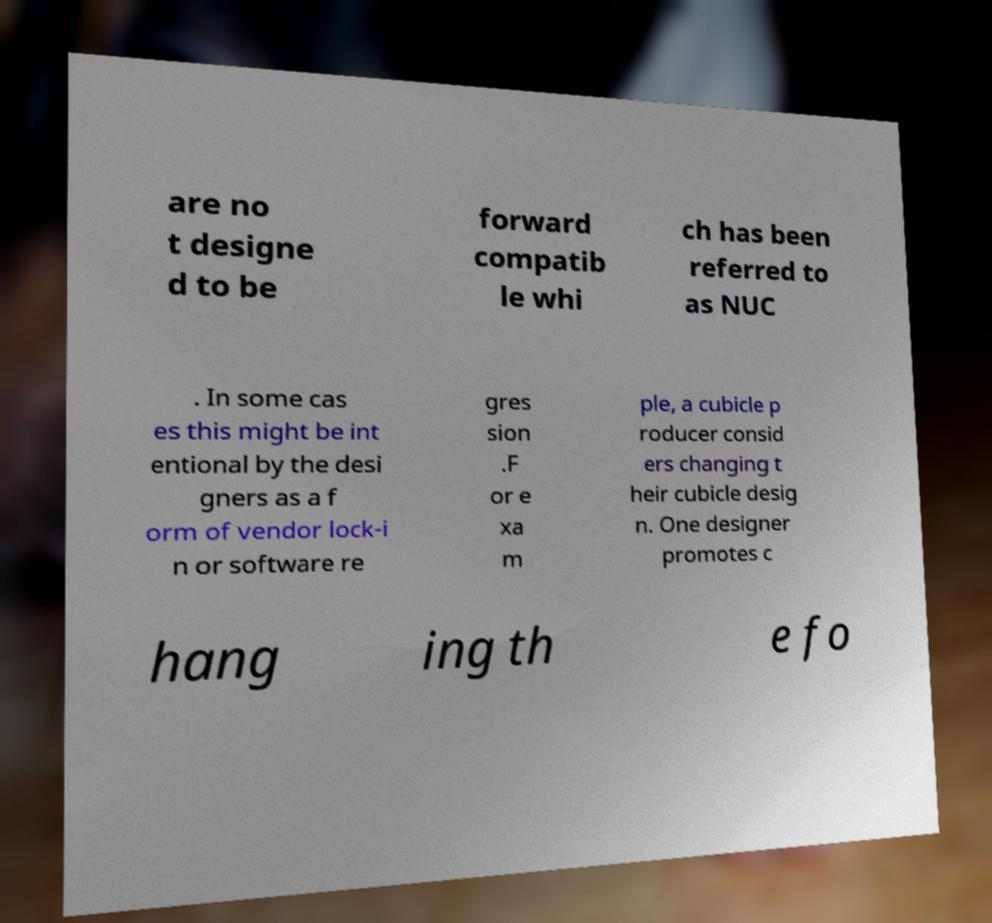For documentation purposes, I need the text within this image transcribed. Could you provide that? are no t designe d to be forward compatib le whi ch has been referred to as NUC . In some cas es this might be int entional by the desi gners as a f orm of vendor lock-i n or software re gres sion .F or e xa m ple, a cubicle p roducer consid ers changing t heir cubicle desig n. One designer promotes c hang ing th e fo 